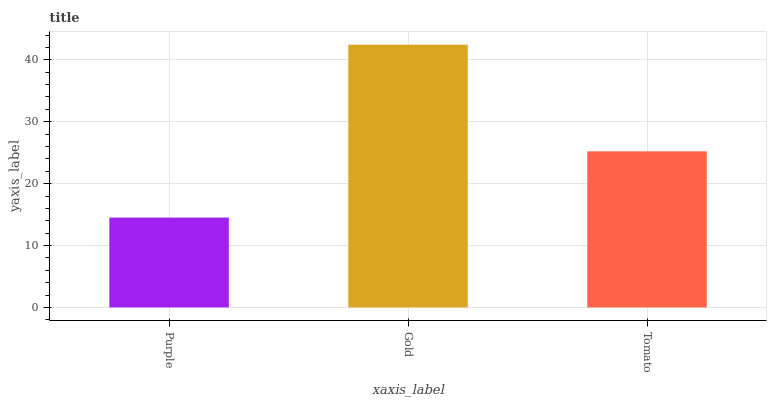Is Tomato the minimum?
Answer yes or no. No. Is Tomato the maximum?
Answer yes or no. No. Is Gold greater than Tomato?
Answer yes or no. Yes. Is Tomato less than Gold?
Answer yes or no. Yes. Is Tomato greater than Gold?
Answer yes or no. No. Is Gold less than Tomato?
Answer yes or no. No. Is Tomato the high median?
Answer yes or no. Yes. Is Tomato the low median?
Answer yes or no. Yes. Is Gold the high median?
Answer yes or no. No. Is Purple the low median?
Answer yes or no. No. 